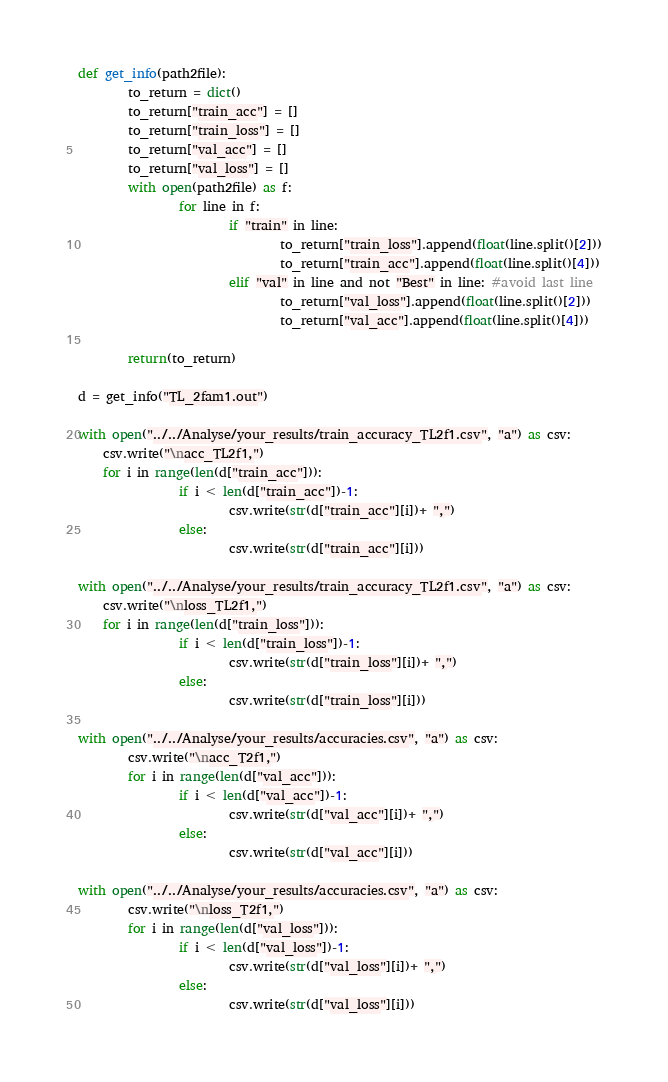<code> <loc_0><loc_0><loc_500><loc_500><_Python_>def get_info(path2file):
        to_return = dict()
        to_return["train_acc"] = []
        to_return["train_loss"] = []
        to_return["val_acc"] = []
        to_return["val_loss"] = []
        with open(path2file) as f:
                for line in f:
                        if "train" in line:
                                to_return["train_loss"].append(float(line.split()[2]))
                                to_return["train_acc"].append(float(line.split()[4]))
                        elif "val" in line and not "Best" in line: #avoid last line
                                to_return["val_loss"].append(float(line.split()[2]))
                                to_return["val_acc"].append(float(line.split()[4]))

        return(to_return)

d = get_info("TL_2fam1.out")

with open("../../Analyse/your_results/train_accuracy_TL2f1.csv", "a") as csv:
	csv.write("\nacc_TL2f1,")
	for i in range(len(d["train_acc"])):
                if i < len(d["train_acc"])-1:
                        csv.write(str(d["train_acc"][i])+ ",")
                else:
                        csv.write(str(d["train_acc"][i]))

with open("../../Analyse/your_results/train_accuracy_TL2f1.csv", "a") as csv:
	csv.write("\nloss_TL2f1,")
	for i in range(len(d["train_loss"])):
                if i < len(d["train_loss"])-1:
                        csv.write(str(d["train_loss"][i])+ ",")
                else:
                        csv.write(str(d["train_loss"][i]))
        
with open("../../Analyse/your_results/accuracies.csv", "a") as csv:
        csv.write("\nacc_T2f1,")
        for i in range(len(d["val_acc"])):
                if i < len(d["val_acc"])-1:
                        csv.write(str(d["val_acc"][i])+ ",")
                else:
                        csv.write(str(d["val_acc"][i]))

with open("../../Analyse/your_results/accuracies.csv", "a") as csv:
        csv.write("\nloss_T2f1,")
        for i in range(len(d["val_loss"])):
                if i < len(d["val_loss"])-1:
                        csv.write(str(d["val_loss"][i])+ ",")
                else:
                        csv.write(str(d["val_loss"][i]))
</code> 